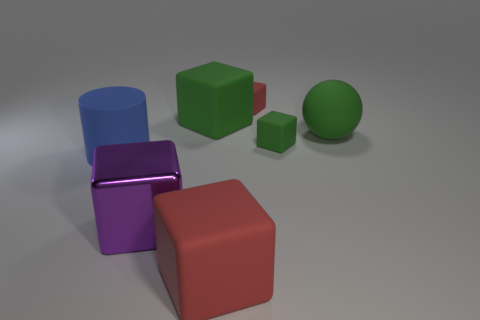Do the matte cylinder and the matte ball have the same size?
Provide a succinct answer. Yes. What is the big object to the left of the purple object made of?
Ensure brevity in your answer.  Rubber. There is another green object that is the same shape as the tiny green rubber object; what is its material?
Offer a terse response. Rubber. There is a big thing in front of the large purple thing; are there any rubber cylinders in front of it?
Ensure brevity in your answer.  No. Does the blue thing have the same shape as the large shiny object?
Offer a terse response. No. What shape is the large red thing that is made of the same material as the blue object?
Give a very brief answer. Cube. There is a thing that is on the left side of the big purple metal cube; is it the same size as the red matte thing behind the large matte cylinder?
Provide a short and direct response. No. Are there more big red rubber things behind the rubber cylinder than large cylinders behind the tiny green rubber thing?
Your response must be concise. No. How many other objects are the same color as the large rubber ball?
Offer a terse response. 2. There is a shiny cube; is it the same color as the big matte thing that is in front of the large cylinder?
Offer a terse response. No. 